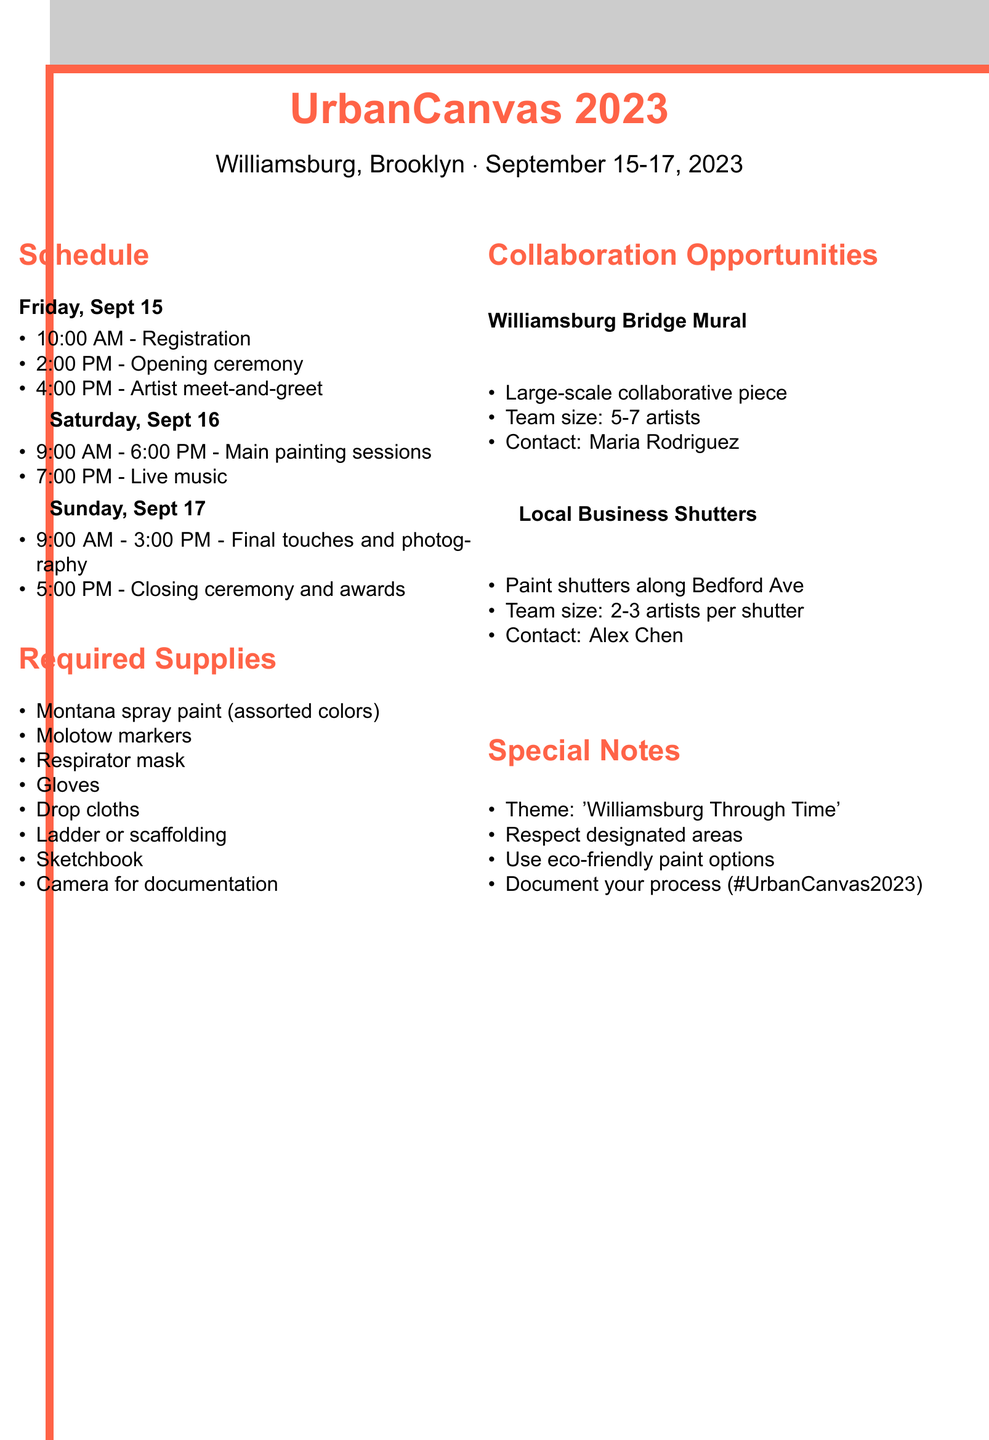What are the festival dates? The festival dates are clearly stated in the document as September 15-17, 2023.
Answer: September 15-17, 2023 Where is the festival located? The location of the festival is mentioned as Williamsburg, Brooklyn in the document.
Answer: Williamsburg, Brooklyn What is one of the required supplies? The document lists several required supplies; one example is Montana spray paint.
Answer: Montana spray paint Who can be contacted for the Williamsburg Bridge Mural project? The document provides contact information for collaboration opportunities, specifically mentioning Maria Rodriguez for the Williamsburg Bridge Mural.
Answer: Maria Rodriguez What is the theme of the festival? The theme is noted in the special notes section, emphasizing the incorporation of historical and modern elements.
Answer: Williamsburg Through Time How many artists are needed for the Williamsburg Bridge Mural? The document specifies that the team size for this project is 5-7 artists.
Answer: 5-7 artists What is scheduled for Saturday at 7:00 PM? The event scheduled for that time is live music at Brooklyn Bowl.
Answer: Live music at Brooklyn Bowl What time does the closing ceremony start? The closing ceremony time is provided in the schedule for Sunday, noting it as starting at 5:00 PM.
Answer: 5:00 PM 